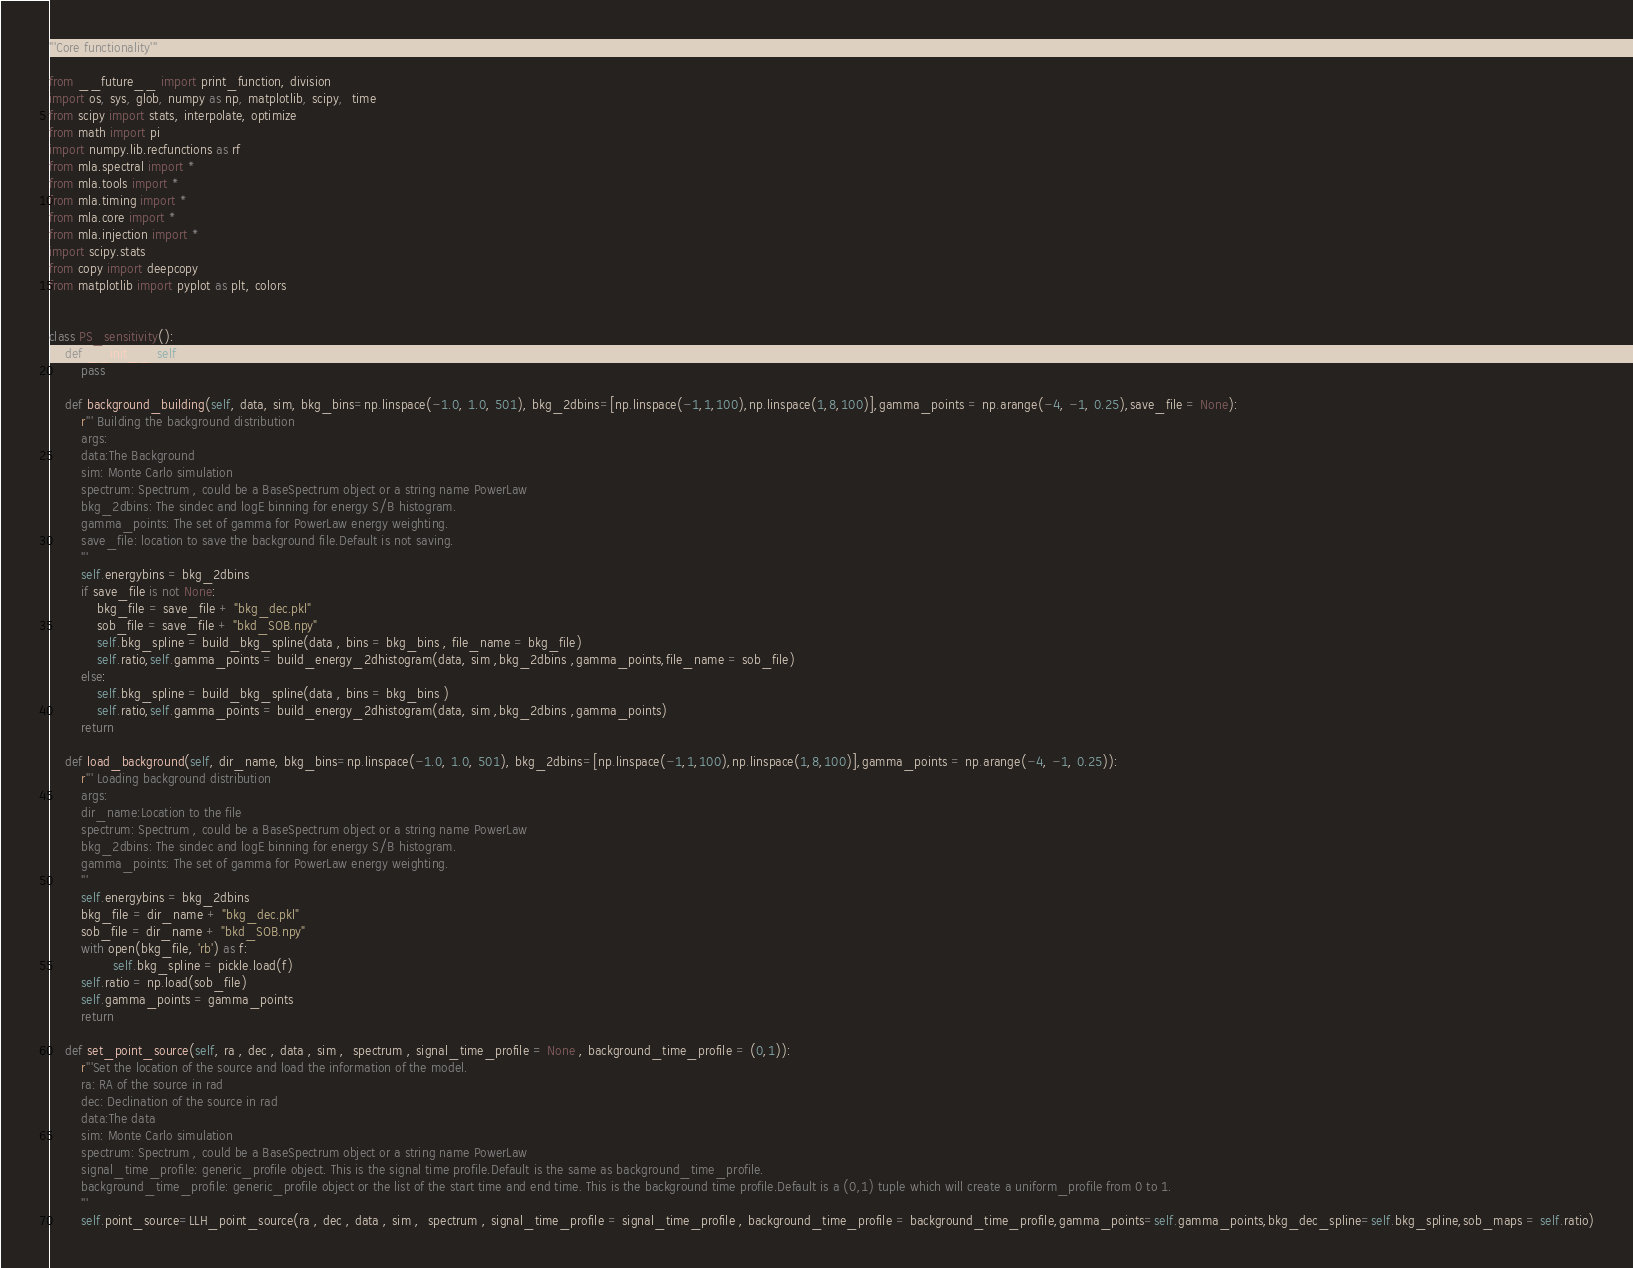<code> <loc_0><loc_0><loc_500><loc_500><_Python_>'''Core functionality'''

from __future__ import print_function, division
import os, sys, glob, numpy as np, matplotlib, scipy,  time
from scipy import stats, interpolate, optimize
from math import pi
import numpy.lib.recfunctions as rf
from mla.spectral import *
from mla.tools import *
from mla.timing import *
from mla.core import *
from mla.injection import *
import scipy.stats
from copy import deepcopy
from matplotlib import pyplot as plt, colors


class PS_sensitivity():
    def __init__(self):
        pass
        
    def background_building(self, data, sim, bkg_bins=np.linspace(-1.0, 1.0, 501), bkg_2dbins=[np.linspace(-1,1,100),np.linspace(1,8,100)],gamma_points = np.arange(-4, -1, 0.25),save_file = None):
        r''' Building the background distribution
        args:
        data:The Background
        sim: Monte Carlo simulation
        spectrum: Spectrum , could be a BaseSpectrum object or a string name PowerLaw
        bkg_2dbins: The sindec and logE binning for energy S/B histogram.
        gamma_points: The set of gamma for PowerLaw energy weighting.
        save_file: location to save the background file.Default is not saving.
        '''
        self.energybins = bkg_2dbins
        if save_file is not None:
            bkg_file = save_file + "bkg_dec.pkl"
            sob_file = save_file + "bkd_SOB.npy"
            self.bkg_spline = build_bkg_spline(data , bins = bkg_bins , file_name = bkg_file)
            self.ratio,self.gamma_points = build_energy_2dhistogram(data, sim ,bkg_2dbins ,gamma_points,file_name = sob_file)
        else:
            self.bkg_spline = build_bkg_spline(data , bins = bkg_bins )
            self.ratio,self.gamma_points = build_energy_2dhistogram(data, sim ,bkg_2dbins ,gamma_points)
        return
    
    def load_background(self, dir_name, bkg_bins=np.linspace(-1.0, 1.0, 501), bkg_2dbins=[np.linspace(-1,1,100),np.linspace(1,8,100)],gamma_points = np.arange(-4, -1, 0.25)):
        r''' Loading background distribution
        args:
        dir_name:Location to the file
        spectrum: Spectrum , could be a BaseSpectrum object or a string name PowerLaw
        bkg_2dbins: The sindec and logE binning for energy S/B histogram.
        gamma_points: The set of gamma for PowerLaw energy weighting.
        '''
        self.energybins = bkg_2dbins
        bkg_file = dir_name + "bkg_dec.pkl"
        sob_file = dir_name + "bkd_SOB.npy"
        with open(bkg_file, 'rb') as f:
                self.bkg_spline = pickle.load(f)
        self.ratio = np.load(sob_file)
        self.gamma_points = gamma_points
        return
    
    def set_point_source(self, ra , dec , data , sim ,  spectrum , signal_time_profile = None , background_time_profile = (0,1)):
        r'''Set the location of the source and load the information of the model.
        ra: RA of the source in rad
        dec: Declination of the source in rad
        data:The data
        sim: Monte Carlo simulation
        spectrum: Spectrum , could be a BaseSpectrum object or a string name PowerLaw
        signal_time_profile: generic_profile object. This is the signal time profile.Default is the same as background_time_profile.
        background_time_profile: generic_profile object or the list of the start time and end time. This is the background time profile.Default is a (0,1) tuple which will create a uniform_profile from 0 to 1.
        '''
        self.point_source=LLH_point_source(ra , dec , data , sim ,  spectrum , signal_time_profile = signal_time_profile , background_time_profile = background_time_profile,gamma_points=self.gamma_points,bkg_dec_spline=self.bkg_spline,sob_maps = self.ratio)</code> 